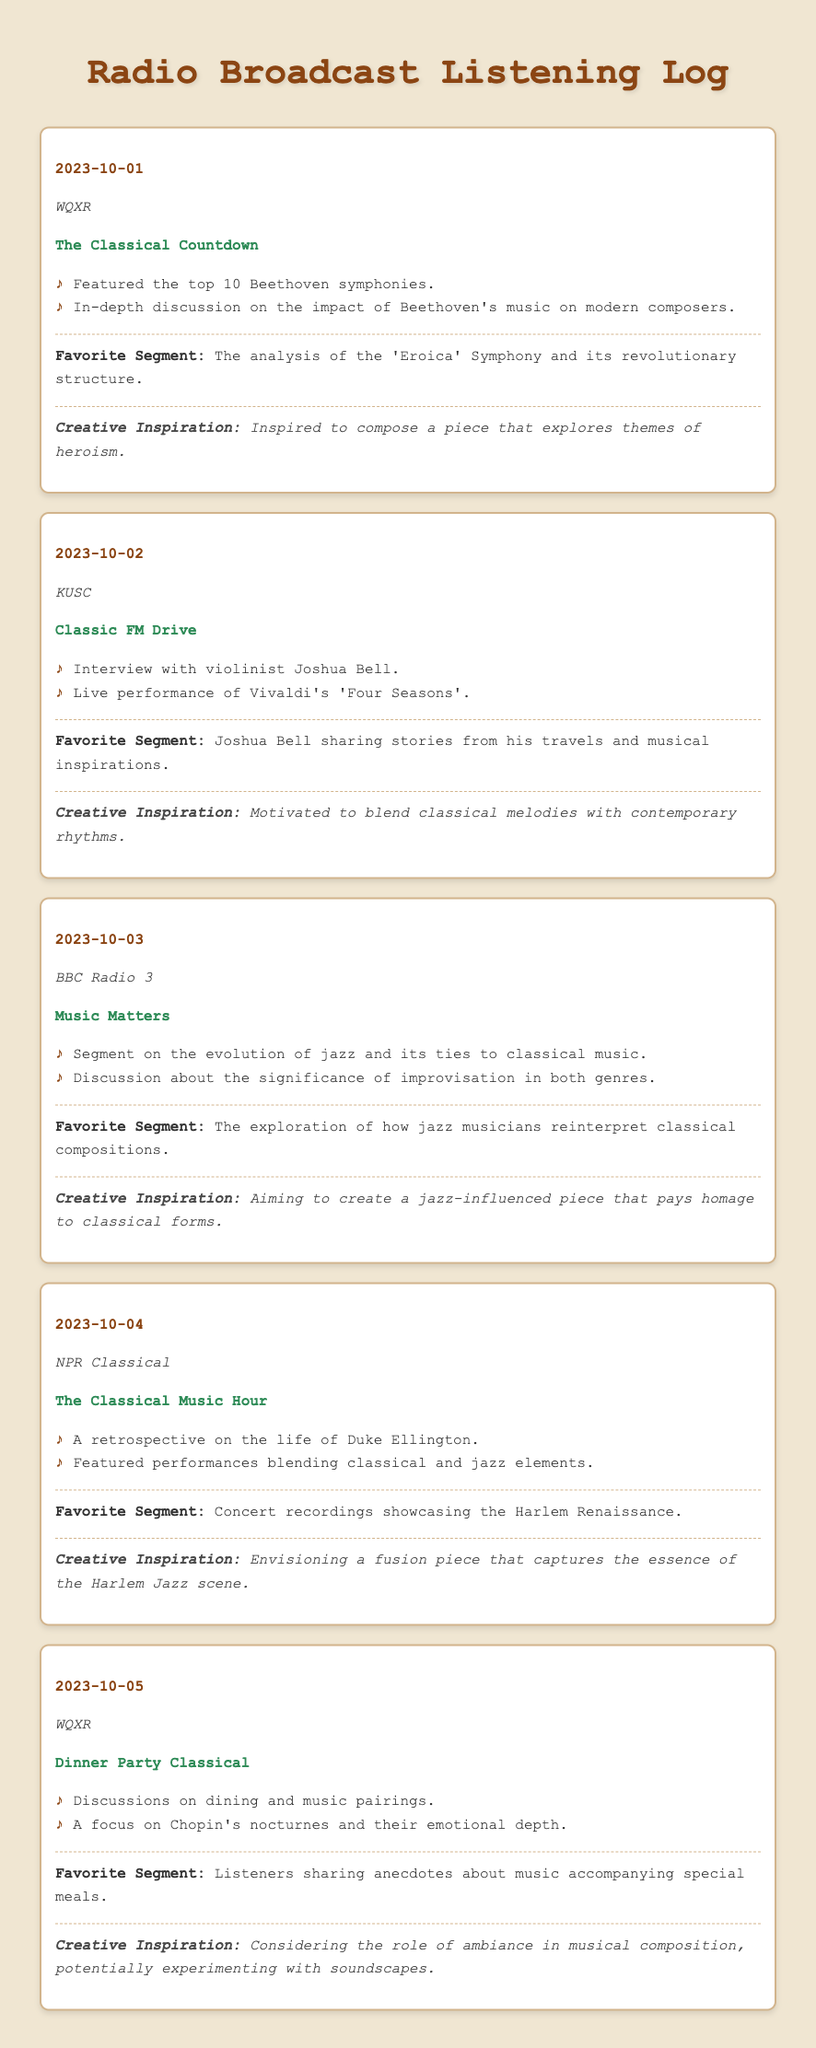What was the broadcast date for the segment about Beethoven? The document lists the date of the broadcast featuring Beethoven as October 1, 2023.
Answer: October 1, 2023 Which station aired "Classic FM Drive"? The document states that "Classic FM Drive" was aired on KUSC.
Answer: KUSC What was the favorite segment related to Duke Ellington? The favorite segment for the broadcast about Duke Ellington discussed performances blending classical and jazz elements.
Answer: Concert recordings showcasing the Harlem Renaissance On what date was the analysis of 'Eroica' Symphony discussed? According to the document, the analysis of the 'Eroica' Symphony was highlighted on October 1, 2023.
Answer: October 1, 2023 Which composer's music was featured on October 5, 2023? The document mentions that Chopin's nocturnes were the focus of the segment on October 5, 2023.
Answer: Chopin What creative inspiration was drawn from the segment featuring Joshua Bell? The inspiration from the Joshua Bell segment was to blend classical melodies with contemporary rhythms.
Answer: Blend classical melodies with contemporary rhythms What was one of the main discussion topics on October 3, 2023? The document indicates that the evolution of jazz and its ties to classical music were discussed.
Answer: Evolution of jazz and its ties to classical music Which broadcast featured an interview with a violinist? The document specifies that the "Classic FM Drive" on KUSC featured an interview with violinist Joshua Bell.
Answer: Classic FM Drive 